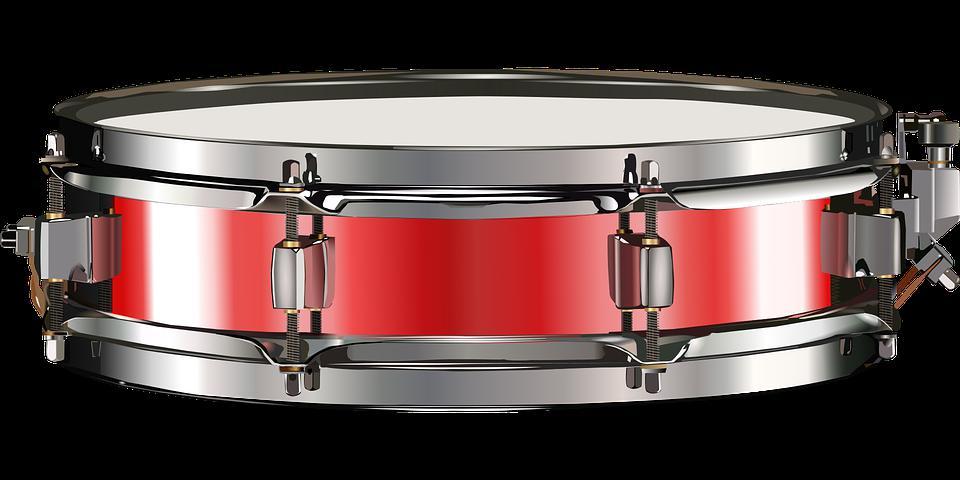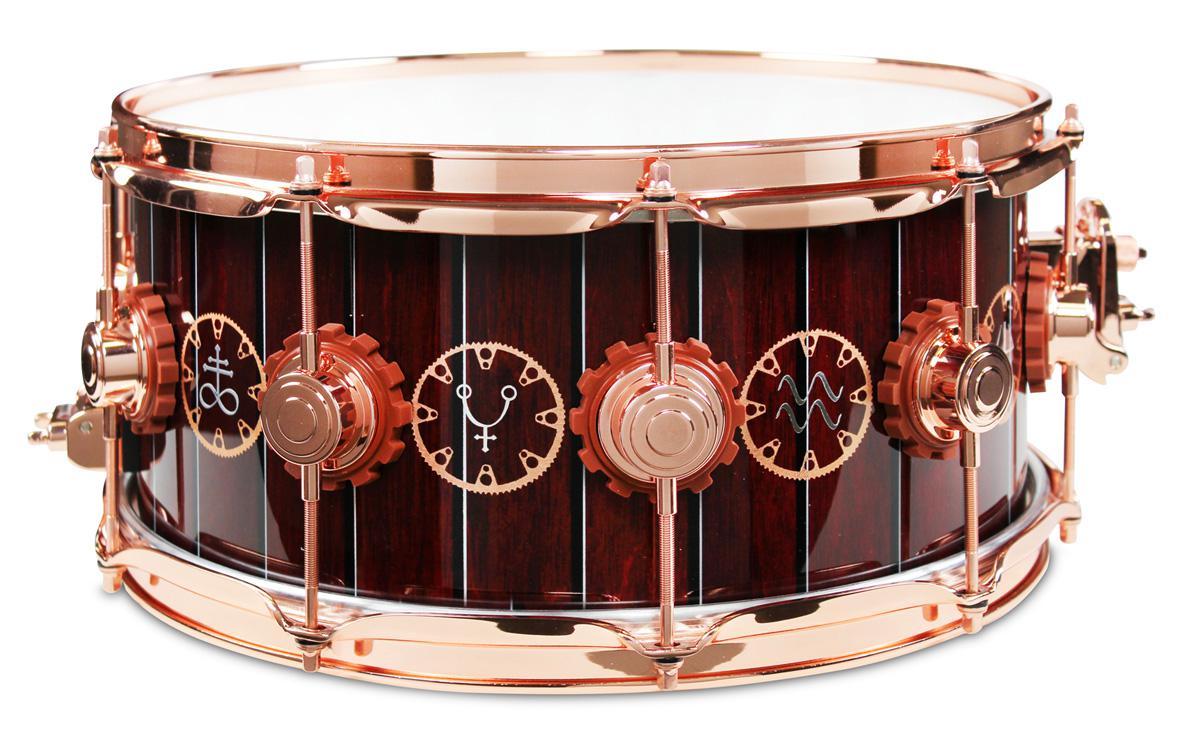The first image is the image on the left, the second image is the image on the right. Analyze the images presented: Is the assertion "The drum on the left has a red exterior with rectangular silver shapes spaced around it, and the drum on the right is brown with round shapes spaced around it." valid? Answer yes or no. Yes. 